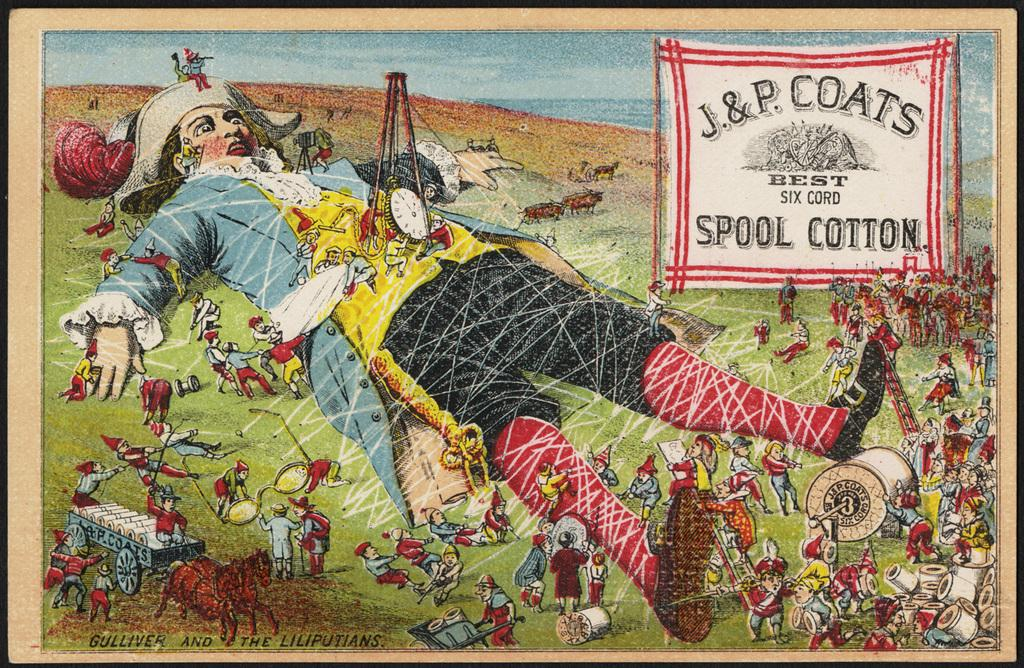<image>
Create a compact narrative representing the image presented. J. & P. Coats have created an advertisement for their spool cotton. 